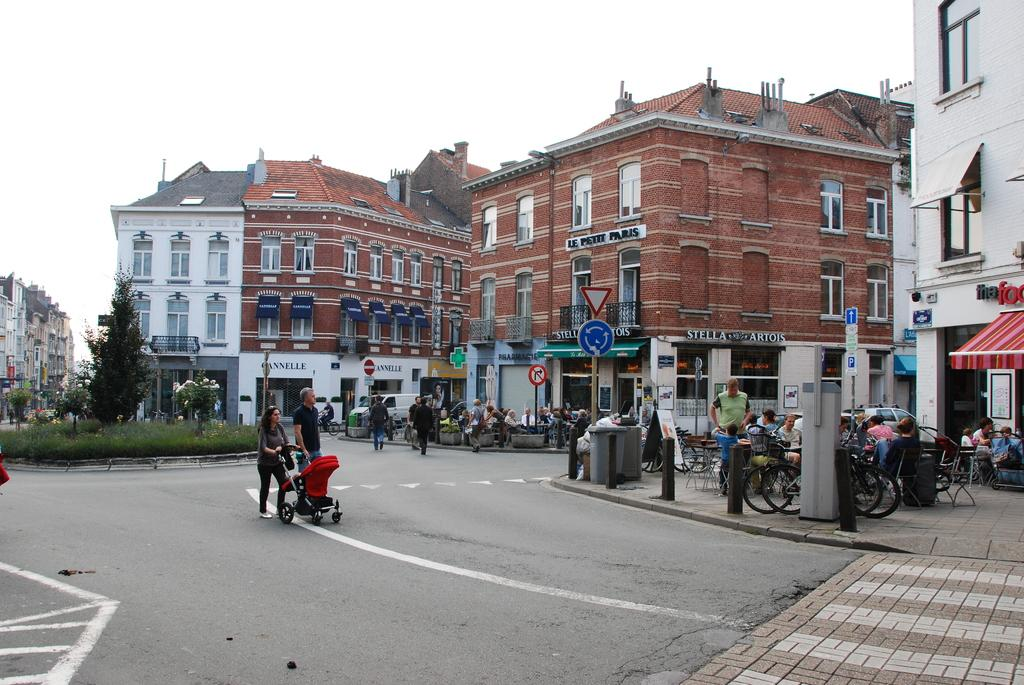What type of structures can be seen in the image? There are buildings with windows in the image. Who or what can be seen in the image besides the buildings? There are people visible in the image. What mode of transportation is present in the image? Bicycles are present in the image. What object might be used for seating a baby or infant? A baby chair is visible in the image. What can be used for disposing of waste in the image? There is a bin in the image. What might be a mode of transportation for the people in the image? A vehicle is present in the image. What can be seen providing information or directions in the image? Sign boards are visible in the image. What type of vegetation is present in the image? Plants are present in the image. What time does the clock show in the image? There is no clock present in the image, so the time cannot be determined. How fast are the people running in the image? There is no one running in the image; the people are stationary. What is covering the plants in the image? There is nothing covering the plants in the image; they are exposed to the environment. 